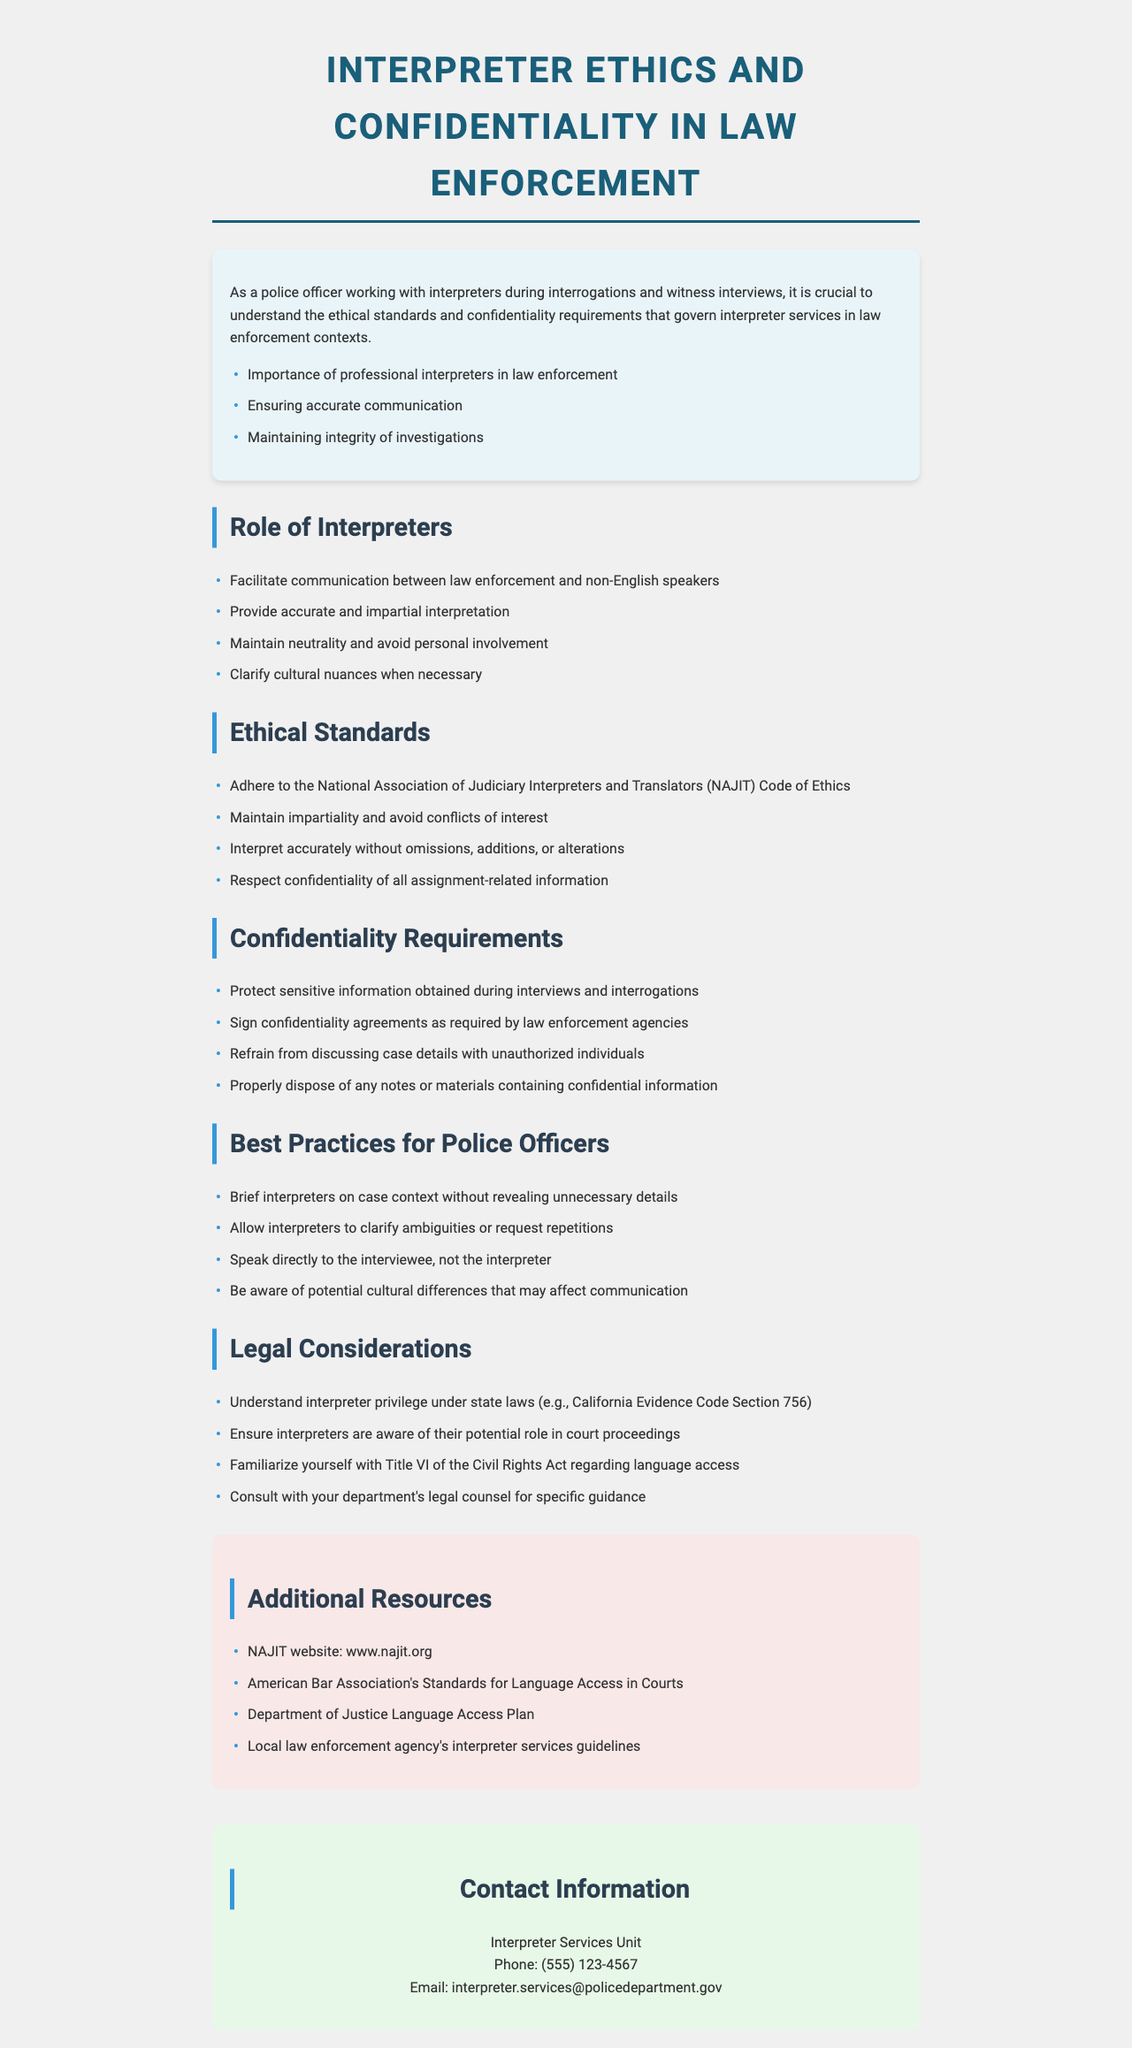what is the title of the brochure? The title is presented at the top of the document, clearly stated for easy identification.
Answer: Interpreter Ethics and Confidentiality in Law Enforcement who adheres to the NAJIT Code of Ethics? The ethical standards outlined in the document specify that interpreters are the ones who adhere to the NAJIT Code of Ethics.
Answer: interpreters what are interpreters required to protect according to confidentiality requirements? The confidentiality requirements clearly state that sensitive information obtained during interviews and interrogations must be protected.
Answer: sensitive information what is one of the best practices for police officers when working with interpreters? The document outlines several best practices for police officers, one of which is to allow interpreters to clarify ambiguities or request repetitions.
Answer: allow interpreters to clarify ambiguities how can interpreters ensure they maintain impartiality? The ethical standards state that interpreters must avoid conflicts of interest to maintain their impartiality.
Answer: avoid conflicts of interest what is the phone number for the Interpreter Services Unit? The contact information section of the document provides the phone number for the Interpreter Services Unit.
Answer: (555) 123-4567 what is the purpose of the brochure? The introduction describes the brochure's purpose, which is to help police officers understand interpreter ethics and confidentiality requirements.
Answer: Understanding interpreter ethics and confidentiality requirements how many sections are in the brochure? The structure of the document suggests that there are multiple sections covering different aspects, specifically outlined after the introduction.
Answer: five sections which act relates to language access mentioned in the legal considerations? The legal considerations section refers directly to Title VI in the context of language access.
Answer: Title VI of the Civil Rights Act 